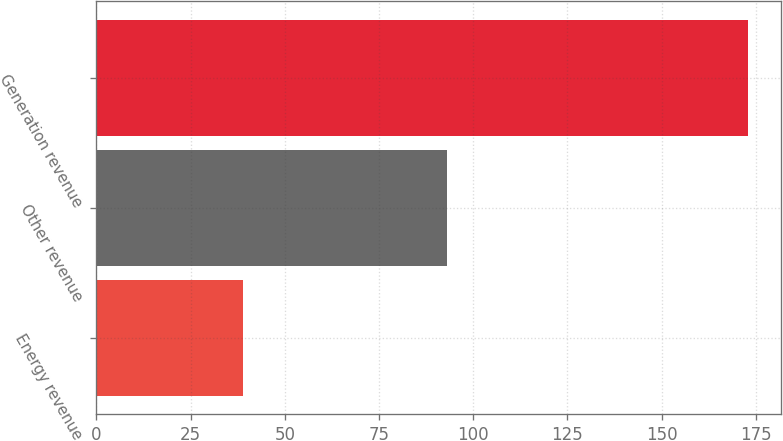Convert chart to OTSL. <chart><loc_0><loc_0><loc_500><loc_500><bar_chart><fcel>Energy revenue<fcel>Other revenue<fcel>Generation revenue<nl><fcel>39<fcel>93<fcel>173<nl></chart> 